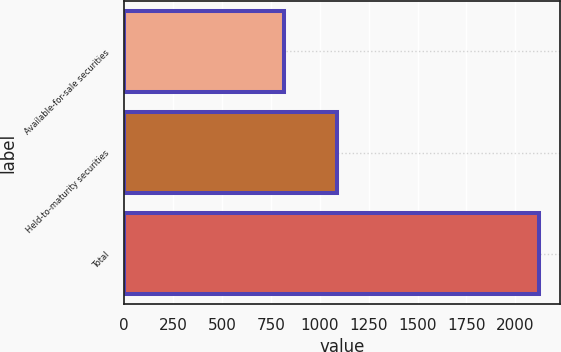<chart> <loc_0><loc_0><loc_500><loc_500><bar_chart><fcel>Available-for-sale securities<fcel>Held-to-maturity securities<fcel>Total<nl><fcel>816<fcel>1087<fcel>2122<nl></chart> 